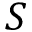<formula> <loc_0><loc_0><loc_500><loc_500>S</formula> 